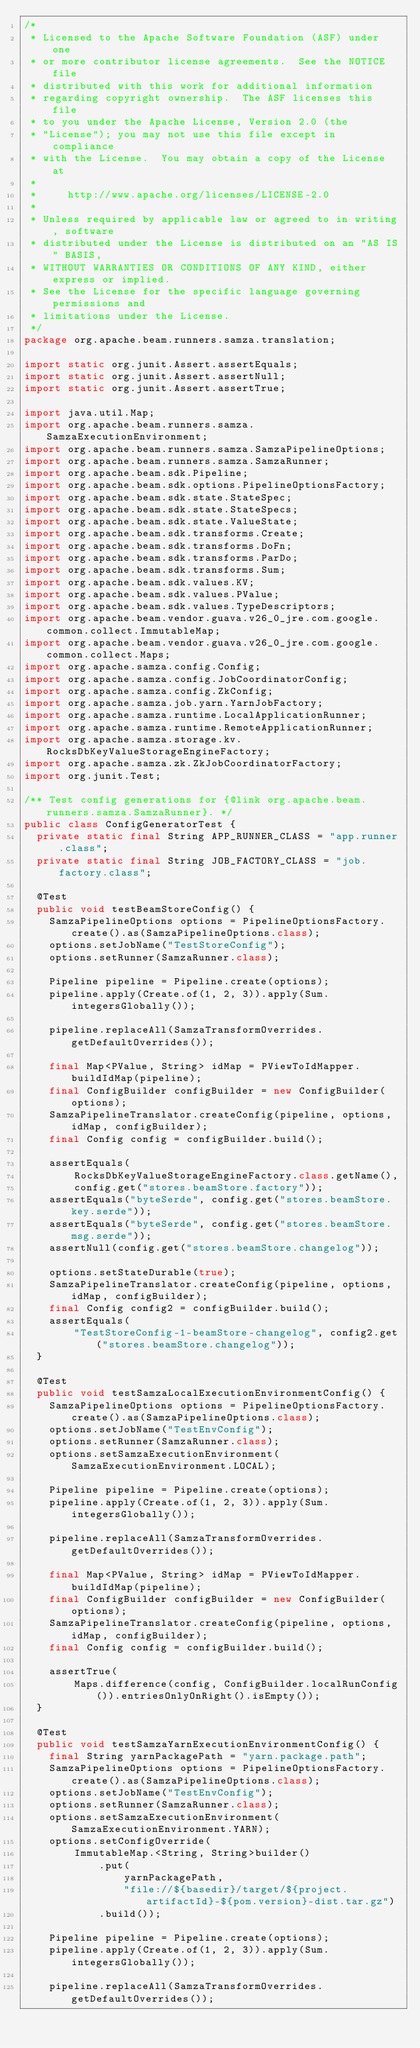<code> <loc_0><loc_0><loc_500><loc_500><_Java_>/*
 * Licensed to the Apache Software Foundation (ASF) under one
 * or more contributor license agreements.  See the NOTICE file
 * distributed with this work for additional information
 * regarding copyright ownership.  The ASF licenses this file
 * to you under the Apache License, Version 2.0 (the
 * "License"); you may not use this file except in compliance
 * with the License.  You may obtain a copy of the License at
 *
 *     http://www.apache.org/licenses/LICENSE-2.0
 *
 * Unless required by applicable law or agreed to in writing, software
 * distributed under the License is distributed on an "AS IS" BASIS,
 * WITHOUT WARRANTIES OR CONDITIONS OF ANY KIND, either express or implied.
 * See the License for the specific language governing permissions and
 * limitations under the License.
 */
package org.apache.beam.runners.samza.translation;

import static org.junit.Assert.assertEquals;
import static org.junit.Assert.assertNull;
import static org.junit.Assert.assertTrue;

import java.util.Map;
import org.apache.beam.runners.samza.SamzaExecutionEnvironment;
import org.apache.beam.runners.samza.SamzaPipelineOptions;
import org.apache.beam.runners.samza.SamzaRunner;
import org.apache.beam.sdk.Pipeline;
import org.apache.beam.sdk.options.PipelineOptionsFactory;
import org.apache.beam.sdk.state.StateSpec;
import org.apache.beam.sdk.state.StateSpecs;
import org.apache.beam.sdk.state.ValueState;
import org.apache.beam.sdk.transforms.Create;
import org.apache.beam.sdk.transforms.DoFn;
import org.apache.beam.sdk.transforms.ParDo;
import org.apache.beam.sdk.transforms.Sum;
import org.apache.beam.sdk.values.KV;
import org.apache.beam.sdk.values.PValue;
import org.apache.beam.sdk.values.TypeDescriptors;
import org.apache.beam.vendor.guava.v26_0_jre.com.google.common.collect.ImmutableMap;
import org.apache.beam.vendor.guava.v26_0_jre.com.google.common.collect.Maps;
import org.apache.samza.config.Config;
import org.apache.samza.config.JobCoordinatorConfig;
import org.apache.samza.config.ZkConfig;
import org.apache.samza.job.yarn.YarnJobFactory;
import org.apache.samza.runtime.LocalApplicationRunner;
import org.apache.samza.runtime.RemoteApplicationRunner;
import org.apache.samza.storage.kv.RocksDbKeyValueStorageEngineFactory;
import org.apache.samza.zk.ZkJobCoordinatorFactory;
import org.junit.Test;

/** Test config generations for {@link org.apache.beam.runners.samza.SamzaRunner}. */
public class ConfigGeneratorTest {
  private static final String APP_RUNNER_CLASS = "app.runner.class";
  private static final String JOB_FACTORY_CLASS = "job.factory.class";

  @Test
  public void testBeamStoreConfig() {
    SamzaPipelineOptions options = PipelineOptionsFactory.create().as(SamzaPipelineOptions.class);
    options.setJobName("TestStoreConfig");
    options.setRunner(SamzaRunner.class);

    Pipeline pipeline = Pipeline.create(options);
    pipeline.apply(Create.of(1, 2, 3)).apply(Sum.integersGlobally());

    pipeline.replaceAll(SamzaTransformOverrides.getDefaultOverrides());

    final Map<PValue, String> idMap = PViewToIdMapper.buildIdMap(pipeline);
    final ConfigBuilder configBuilder = new ConfigBuilder(options);
    SamzaPipelineTranslator.createConfig(pipeline, options, idMap, configBuilder);
    final Config config = configBuilder.build();

    assertEquals(
        RocksDbKeyValueStorageEngineFactory.class.getName(),
        config.get("stores.beamStore.factory"));
    assertEquals("byteSerde", config.get("stores.beamStore.key.serde"));
    assertEquals("byteSerde", config.get("stores.beamStore.msg.serde"));
    assertNull(config.get("stores.beamStore.changelog"));

    options.setStateDurable(true);
    SamzaPipelineTranslator.createConfig(pipeline, options, idMap, configBuilder);
    final Config config2 = configBuilder.build();
    assertEquals(
        "TestStoreConfig-1-beamStore-changelog", config2.get("stores.beamStore.changelog"));
  }

  @Test
  public void testSamzaLocalExecutionEnvironmentConfig() {
    SamzaPipelineOptions options = PipelineOptionsFactory.create().as(SamzaPipelineOptions.class);
    options.setJobName("TestEnvConfig");
    options.setRunner(SamzaRunner.class);
    options.setSamzaExecutionEnvironment(SamzaExecutionEnvironment.LOCAL);

    Pipeline pipeline = Pipeline.create(options);
    pipeline.apply(Create.of(1, 2, 3)).apply(Sum.integersGlobally());

    pipeline.replaceAll(SamzaTransformOverrides.getDefaultOverrides());

    final Map<PValue, String> idMap = PViewToIdMapper.buildIdMap(pipeline);
    final ConfigBuilder configBuilder = new ConfigBuilder(options);
    SamzaPipelineTranslator.createConfig(pipeline, options, idMap, configBuilder);
    final Config config = configBuilder.build();

    assertTrue(
        Maps.difference(config, ConfigBuilder.localRunConfig()).entriesOnlyOnRight().isEmpty());
  }

  @Test
  public void testSamzaYarnExecutionEnvironmentConfig() {
    final String yarnPackagePath = "yarn.package.path";
    SamzaPipelineOptions options = PipelineOptionsFactory.create().as(SamzaPipelineOptions.class);
    options.setJobName("TestEnvConfig");
    options.setRunner(SamzaRunner.class);
    options.setSamzaExecutionEnvironment(SamzaExecutionEnvironment.YARN);
    options.setConfigOverride(
        ImmutableMap.<String, String>builder()
            .put(
                yarnPackagePath,
                "file://${basedir}/target/${project.artifactId}-${pom.version}-dist.tar.gz")
            .build());

    Pipeline pipeline = Pipeline.create(options);
    pipeline.apply(Create.of(1, 2, 3)).apply(Sum.integersGlobally());

    pipeline.replaceAll(SamzaTransformOverrides.getDefaultOverrides());
</code> 